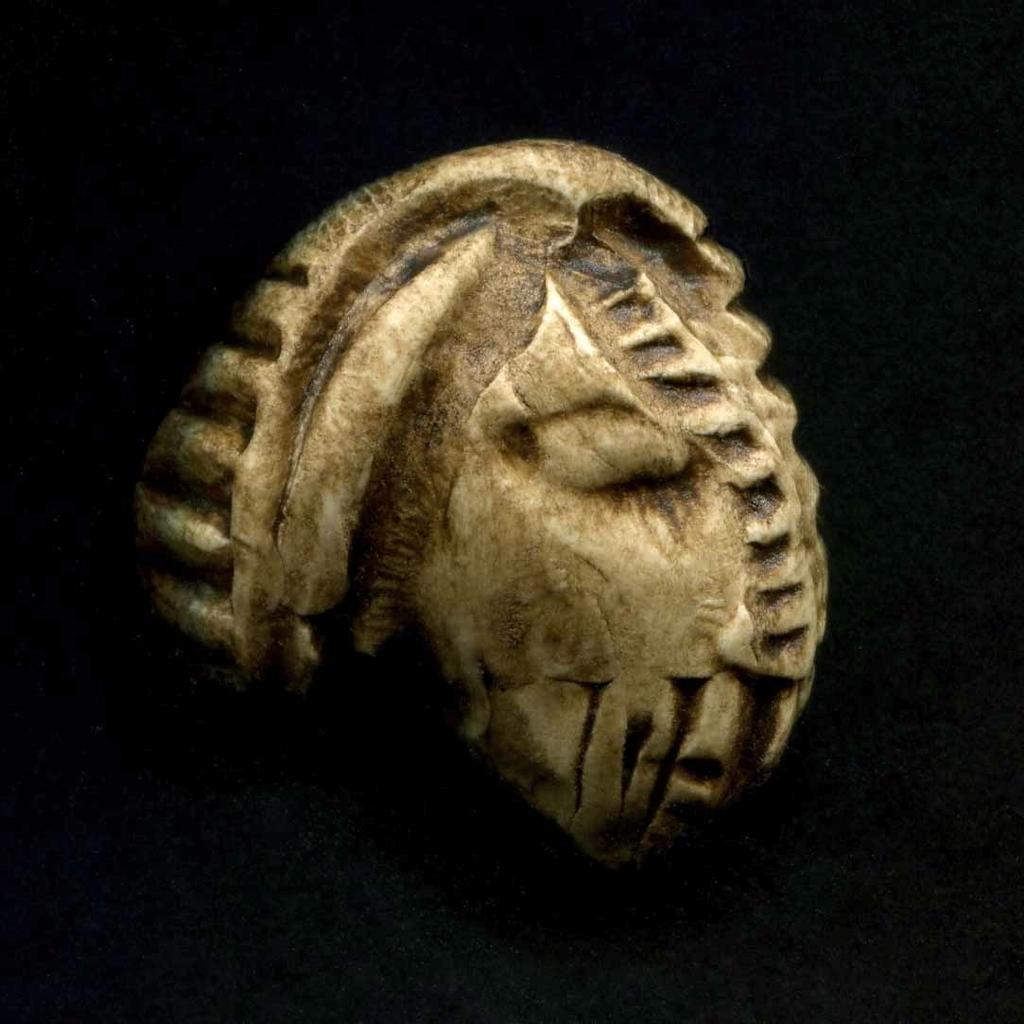What can be seen in the image? There is an object in the image. What is the color of the background in the image? The background of the image is dark. Can you see any fish swimming in the lake in the image? There is no lake present in the image, so it is not possible to see any fish swimming in it. 